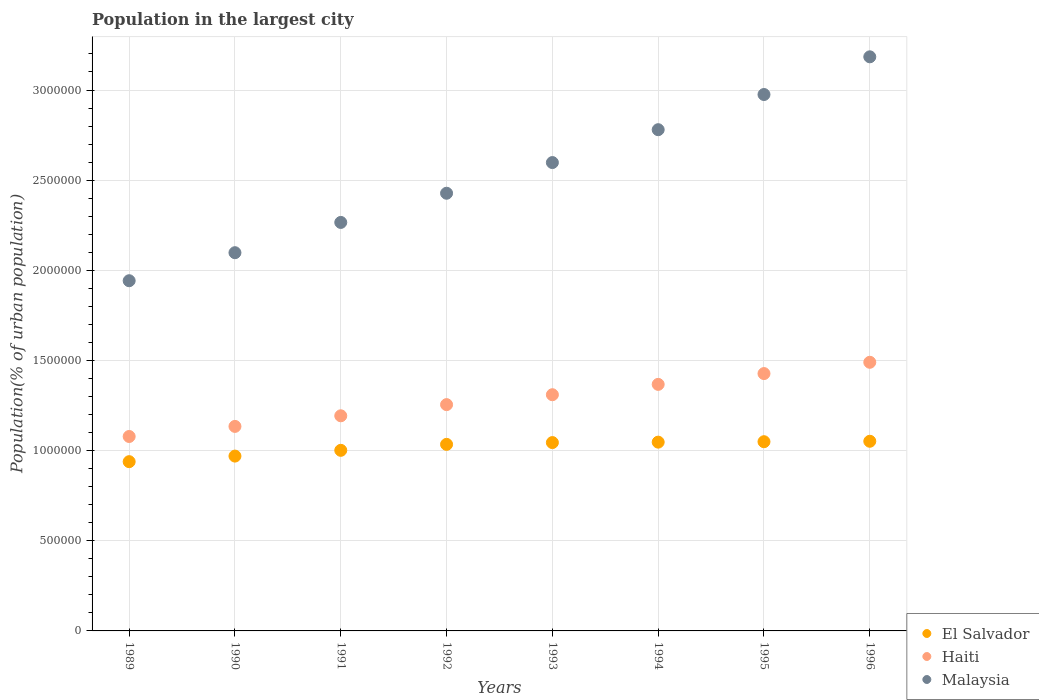What is the population in the largest city in Haiti in 1990?
Offer a terse response. 1.13e+06. Across all years, what is the maximum population in the largest city in Haiti?
Your answer should be compact. 1.49e+06. Across all years, what is the minimum population in the largest city in El Salvador?
Give a very brief answer. 9.39e+05. In which year was the population in the largest city in El Salvador minimum?
Make the answer very short. 1989. What is the total population in the largest city in Haiti in the graph?
Keep it short and to the point. 1.03e+07. What is the difference between the population in the largest city in Haiti in 1995 and that in 1996?
Offer a very short reply. -6.26e+04. What is the difference between the population in the largest city in Haiti in 1991 and the population in the largest city in Malaysia in 1989?
Make the answer very short. -7.49e+05. What is the average population in the largest city in El Salvador per year?
Provide a short and direct response. 1.02e+06. In the year 1989, what is the difference between the population in the largest city in El Salvador and population in the largest city in Malaysia?
Provide a short and direct response. -1.00e+06. What is the ratio of the population in the largest city in Haiti in 1989 to that in 1994?
Your response must be concise. 0.79. Is the population in the largest city in El Salvador in 1991 less than that in 1992?
Your answer should be very brief. Yes. What is the difference between the highest and the second highest population in the largest city in Haiti?
Offer a very short reply. 6.26e+04. What is the difference between the highest and the lowest population in the largest city in Haiti?
Keep it short and to the point. 4.12e+05. In how many years, is the population in the largest city in Haiti greater than the average population in the largest city in Haiti taken over all years?
Ensure brevity in your answer.  4. Does the population in the largest city in Malaysia monotonically increase over the years?
Your answer should be compact. Yes. Is the population in the largest city in El Salvador strictly greater than the population in the largest city in Haiti over the years?
Offer a very short reply. No. Is the population in the largest city in Malaysia strictly less than the population in the largest city in Haiti over the years?
Give a very brief answer. No. What is the difference between two consecutive major ticks on the Y-axis?
Keep it short and to the point. 5.00e+05. Does the graph contain any zero values?
Ensure brevity in your answer.  No. Does the graph contain grids?
Your answer should be compact. Yes. Where does the legend appear in the graph?
Your answer should be compact. Bottom right. How are the legend labels stacked?
Offer a terse response. Vertical. What is the title of the graph?
Ensure brevity in your answer.  Population in the largest city. What is the label or title of the X-axis?
Provide a short and direct response. Years. What is the label or title of the Y-axis?
Keep it short and to the point. Population(% of urban population). What is the Population(% of urban population) in El Salvador in 1989?
Ensure brevity in your answer.  9.39e+05. What is the Population(% of urban population) of Haiti in 1989?
Ensure brevity in your answer.  1.08e+06. What is the Population(% of urban population) of Malaysia in 1989?
Your response must be concise. 1.94e+06. What is the Population(% of urban population) of El Salvador in 1990?
Your answer should be compact. 9.70e+05. What is the Population(% of urban population) of Haiti in 1990?
Your answer should be compact. 1.13e+06. What is the Population(% of urban population) of Malaysia in 1990?
Offer a very short reply. 2.10e+06. What is the Population(% of urban population) in El Salvador in 1991?
Provide a succinct answer. 1.00e+06. What is the Population(% of urban population) of Haiti in 1991?
Offer a very short reply. 1.19e+06. What is the Population(% of urban population) of Malaysia in 1991?
Give a very brief answer. 2.27e+06. What is the Population(% of urban population) of El Salvador in 1992?
Your answer should be very brief. 1.03e+06. What is the Population(% of urban population) of Haiti in 1992?
Your answer should be compact. 1.26e+06. What is the Population(% of urban population) in Malaysia in 1992?
Provide a succinct answer. 2.43e+06. What is the Population(% of urban population) of El Salvador in 1993?
Your answer should be very brief. 1.04e+06. What is the Population(% of urban population) of Haiti in 1993?
Offer a terse response. 1.31e+06. What is the Population(% of urban population) of Malaysia in 1993?
Offer a very short reply. 2.60e+06. What is the Population(% of urban population) in El Salvador in 1994?
Your answer should be very brief. 1.05e+06. What is the Population(% of urban population) of Haiti in 1994?
Offer a terse response. 1.37e+06. What is the Population(% of urban population) in Malaysia in 1994?
Offer a very short reply. 2.78e+06. What is the Population(% of urban population) of El Salvador in 1995?
Give a very brief answer. 1.05e+06. What is the Population(% of urban population) of Haiti in 1995?
Ensure brevity in your answer.  1.43e+06. What is the Population(% of urban population) of Malaysia in 1995?
Provide a succinct answer. 2.97e+06. What is the Population(% of urban population) of El Salvador in 1996?
Ensure brevity in your answer.  1.05e+06. What is the Population(% of urban population) of Haiti in 1996?
Offer a terse response. 1.49e+06. What is the Population(% of urban population) of Malaysia in 1996?
Give a very brief answer. 3.18e+06. Across all years, what is the maximum Population(% of urban population) in El Salvador?
Provide a short and direct response. 1.05e+06. Across all years, what is the maximum Population(% of urban population) of Haiti?
Make the answer very short. 1.49e+06. Across all years, what is the maximum Population(% of urban population) of Malaysia?
Give a very brief answer. 3.18e+06. Across all years, what is the minimum Population(% of urban population) of El Salvador?
Keep it short and to the point. 9.39e+05. Across all years, what is the minimum Population(% of urban population) of Haiti?
Provide a succinct answer. 1.08e+06. Across all years, what is the minimum Population(% of urban population) in Malaysia?
Your response must be concise. 1.94e+06. What is the total Population(% of urban population) in El Salvador in the graph?
Ensure brevity in your answer.  8.14e+06. What is the total Population(% of urban population) in Haiti in the graph?
Make the answer very short. 1.03e+07. What is the total Population(% of urban population) of Malaysia in the graph?
Ensure brevity in your answer.  2.03e+07. What is the difference between the Population(% of urban population) in El Salvador in 1989 and that in 1990?
Ensure brevity in your answer.  -3.09e+04. What is the difference between the Population(% of urban population) of Haiti in 1989 and that in 1990?
Your response must be concise. -5.59e+04. What is the difference between the Population(% of urban population) in Malaysia in 1989 and that in 1990?
Give a very brief answer. -1.55e+05. What is the difference between the Population(% of urban population) in El Salvador in 1989 and that in 1991?
Keep it short and to the point. -6.29e+04. What is the difference between the Population(% of urban population) of Haiti in 1989 and that in 1991?
Keep it short and to the point. -1.15e+05. What is the difference between the Population(% of urban population) in Malaysia in 1989 and that in 1991?
Your answer should be very brief. -3.23e+05. What is the difference between the Population(% of urban population) in El Salvador in 1989 and that in 1992?
Your answer should be very brief. -9.59e+04. What is the difference between the Population(% of urban population) in Haiti in 1989 and that in 1992?
Ensure brevity in your answer.  -1.77e+05. What is the difference between the Population(% of urban population) in Malaysia in 1989 and that in 1992?
Your answer should be compact. -4.85e+05. What is the difference between the Population(% of urban population) of El Salvador in 1989 and that in 1993?
Your answer should be very brief. -1.06e+05. What is the difference between the Population(% of urban population) of Haiti in 1989 and that in 1993?
Your answer should be very brief. -2.32e+05. What is the difference between the Population(% of urban population) of Malaysia in 1989 and that in 1993?
Ensure brevity in your answer.  -6.55e+05. What is the difference between the Population(% of urban population) of El Salvador in 1989 and that in 1994?
Your answer should be very brief. -1.08e+05. What is the difference between the Population(% of urban population) of Haiti in 1989 and that in 1994?
Keep it short and to the point. -2.89e+05. What is the difference between the Population(% of urban population) of Malaysia in 1989 and that in 1994?
Make the answer very short. -8.38e+05. What is the difference between the Population(% of urban population) of El Salvador in 1989 and that in 1995?
Ensure brevity in your answer.  -1.11e+05. What is the difference between the Population(% of urban population) of Haiti in 1989 and that in 1995?
Make the answer very short. -3.49e+05. What is the difference between the Population(% of urban population) of Malaysia in 1989 and that in 1995?
Your response must be concise. -1.03e+06. What is the difference between the Population(% of urban population) in El Salvador in 1989 and that in 1996?
Provide a short and direct response. -1.13e+05. What is the difference between the Population(% of urban population) of Haiti in 1989 and that in 1996?
Make the answer very short. -4.12e+05. What is the difference between the Population(% of urban population) in Malaysia in 1989 and that in 1996?
Ensure brevity in your answer.  -1.24e+06. What is the difference between the Population(% of urban population) of El Salvador in 1990 and that in 1991?
Provide a succinct answer. -3.20e+04. What is the difference between the Population(% of urban population) in Haiti in 1990 and that in 1991?
Your answer should be compact. -5.88e+04. What is the difference between the Population(% of urban population) of Malaysia in 1990 and that in 1991?
Provide a short and direct response. -1.68e+05. What is the difference between the Population(% of urban population) in El Salvador in 1990 and that in 1992?
Offer a very short reply. -6.50e+04. What is the difference between the Population(% of urban population) of Haiti in 1990 and that in 1992?
Keep it short and to the point. -1.21e+05. What is the difference between the Population(% of urban population) of Malaysia in 1990 and that in 1992?
Your response must be concise. -3.30e+05. What is the difference between the Population(% of urban population) of El Salvador in 1990 and that in 1993?
Offer a terse response. -7.49e+04. What is the difference between the Population(% of urban population) of Haiti in 1990 and that in 1993?
Offer a terse response. -1.76e+05. What is the difference between the Population(% of urban population) in Malaysia in 1990 and that in 1993?
Provide a short and direct response. -5.00e+05. What is the difference between the Population(% of urban population) of El Salvador in 1990 and that in 1994?
Your response must be concise. -7.74e+04. What is the difference between the Population(% of urban population) of Haiti in 1990 and that in 1994?
Provide a succinct answer. -2.33e+05. What is the difference between the Population(% of urban population) of Malaysia in 1990 and that in 1994?
Provide a short and direct response. -6.82e+05. What is the difference between the Population(% of urban population) in El Salvador in 1990 and that in 1995?
Provide a short and direct response. -7.98e+04. What is the difference between the Population(% of urban population) in Haiti in 1990 and that in 1995?
Offer a very short reply. -2.93e+05. What is the difference between the Population(% of urban population) in Malaysia in 1990 and that in 1995?
Offer a very short reply. -8.77e+05. What is the difference between the Population(% of urban population) of El Salvador in 1990 and that in 1996?
Your response must be concise. -8.22e+04. What is the difference between the Population(% of urban population) in Haiti in 1990 and that in 1996?
Make the answer very short. -3.56e+05. What is the difference between the Population(% of urban population) of Malaysia in 1990 and that in 1996?
Offer a very short reply. -1.09e+06. What is the difference between the Population(% of urban population) in El Salvador in 1991 and that in 1992?
Give a very brief answer. -3.31e+04. What is the difference between the Population(% of urban population) of Haiti in 1991 and that in 1992?
Keep it short and to the point. -6.20e+04. What is the difference between the Population(% of urban population) of Malaysia in 1991 and that in 1992?
Provide a succinct answer. -1.62e+05. What is the difference between the Population(% of urban population) of El Salvador in 1991 and that in 1993?
Make the answer very short. -4.30e+04. What is the difference between the Population(% of urban population) in Haiti in 1991 and that in 1993?
Provide a succinct answer. -1.17e+05. What is the difference between the Population(% of urban population) in Malaysia in 1991 and that in 1993?
Provide a succinct answer. -3.32e+05. What is the difference between the Population(% of urban population) in El Salvador in 1991 and that in 1994?
Ensure brevity in your answer.  -4.54e+04. What is the difference between the Population(% of urban population) of Haiti in 1991 and that in 1994?
Provide a short and direct response. -1.74e+05. What is the difference between the Population(% of urban population) of Malaysia in 1991 and that in 1994?
Give a very brief answer. -5.14e+05. What is the difference between the Population(% of urban population) of El Salvador in 1991 and that in 1995?
Make the answer very short. -4.78e+04. What is the difference between the Population(% of urban population) of Haiti in 1991 and that in 1995?
Offer a very short reply. -2.34e+05. What is the difference between the Population(% of urban population) in Malaysia in 1991 and that in 1995?
Provide a succinct answer. -7.09e+05. What is the difference between the Population(% of urban population) of El Salvador in 1991 and that in 1996?
Your answer should be very brief. -5.03e+04. What is the difference between the Population(% of urban population) in Haiti in 1991 and that in 1996?
Provide a succinct answer. -2.97e+05. What is the difference between the Population(% of urban population) of Malaysia in 1991 and that in 1996?
Your answer should be very brief. -9.19e+05. What is the difference between the Population(% of urban population) in El Salvador in 1992 and that in 1993?
Give a very brief answer. -9927. What is the difference between the Population(% of urban population) of Haiti in 1992 and that in 1993?
Make the answer very short. -5.49e+04. What is the difference between the Population(% of urban population) in Malaysia in 1992 and that in 1993?
Provide a succinct answer. -1.70e+05. What is the difference between the Population(% of urban population) in El Salvador in 1992 and that in 1994?
Your answer should be compact. -1.23e+04. What is the difference between the Population(% of urban population) of Haiti in 1992 and that in 1994?
Your answer should be compact. -1.12e+05. What is the difference between the Population(% of urban population) in Malaysia in 1992 and that in 1994?
Ensure brevity in your answer.  -3.52e+05. What is the difference between the Population(% of urban population) in El Salvador in 1992 and that in 1995?
Offer a terse response. -1.48e+04. What is the difference between the Population(% of urban population) in Haiti in 1992 and that in 1995?
Offer a terse response. -1.72e+05. What is the difference between the Population(% of urban population) in Malaysia in 1992 and that in 1995?
Offer a very short reply. -5.48e+05. What is the difference between the Population(% of urban population) of El Salvador in 1992 and that in 1996?
Offer a terse response. -1.72e+04. What is the difference between the Population(% of urban population) in Haiti in 1992 and that in 1996?
Make the answer very short. -2.35e+05. What is the difference between the Population(% of urban population) of Malaysia in 1992 and that in 1996?
Ensure brevity in your answer.  -7.57e+05. What is the difference between the Population(% of urban population) in El Salvador in 1993 and that in 1994?
Your answer should be compact. -2417. What is the difference between the Population(% of urban population) in Haiti in 1993 and that in 1994?
Provide a succinct answer. -5.74e+04. What is the difference between the Population(% of urban population) in Malaysia in 1993 and that in 1994?
Your answer should be compact. -1.82e+05. What is the difference between the Population(% of urban population) of El Salvador in 1993 and that in 1995?
Your answer should be very brief. -4839. What is the difference between the Population(% of urban population) in Haiti in 1993 and that in 1995?
Provide a succinct answer. -1.17e+05. What is the difference between the Population(% of urban population) of Malaysia in 1993 and that in 1995?
Your answer should be compact. -3.77e+05. What is the difference between the Population(% of urban population) in El Salvador in 1993 and that in 1996?
Make the answer very short. -7271. What is the difference between the Population(% of urban population) of Haiti in 1993 and that in 1996?
Your answer should be compact. -1.80e+05. What is the difference between the Population(% of urban population) in Malaysia in 1993 and that in 1996?
Give a very brief answer. -5.86e+05. What is the difference between the Population(% of urban population) of El Salvador in 1994 and that in 1995?
Offer a terse response. -2422. What is the difference between the Population(% of urban population) of Haiti in 1994 and that in 1995?
Make the answer very short. -5.99e+04. What is the difference between the Population(% of urban population) in Malaysia in 1994 and that in 1995?
Offer a very short reply. -1.95e+05. What is the difference between the Population(% of urban population) of El Salvador in 1994 and that in 1996?
Your answer should be very brief. -4854. What is the difference between the Population(% of urban population) in Haiti in 1994 and that in 1996?
Provide a succinct answer. -1.23e+05. What is the difference between the Population(% of urban population) of Malaysia in 1994 and that in 1996?
Provide a short and direct response. -4.04e+05. What is the difference between the Population(% of urban population) in El Salvador in 1995 and that in 1996?
Offer a terse response. -2432. What is the difference between the Population(% of urban population) of Haiti in 1995 and that in 1996?
Your answer should be very brief. -6.26e+04. What is the difference between the Population(% of urban population) of Malaysia in 1995 and that in 1996?
Provide a short and direct response. -2.09e+05. What is the difference between the Population(% of urban population) in El Salvador in 1989 and the Population(% of urban population) in Haiti in 1990?
Ensure brevity in your answer.  -1.96e+05. What is the difference between the Population(% of urban population) of El Salvador in 1989 and the Population(% of urban population) of Malaysia in 1990?
Give a very brief answer. -1.16e+06. What is the difference between the Population(% of urban population) of Haiti in 1989 and the Population(% of urban population) of Malaysia in 1990?
Make the answer very short. -1.02e+06. What is the difference between the Population(% of urban population) in El Salvador in 1989 and the Population(% of urban population) in Haiti in 1991?
Your answer should be compact. -2.54e+05. What is the difference between the Population(% of urban population) in El Salvador in 1989 and the Population(% of urban population) in Malaysia in 1991?
Give a very brief answer. -1.33e+06. What is the difference between the Population(% of urban population) of Haiti in 1989 and the Population(% of urban population) of Malaysia in 1991?
Provide a succinct answer. -1.19e+06. What is the difference between the Population(% of urban population) of El Salvador in 1989 and the Population(% of urban population) of Haiti in 1992?
Your answer should be very brief. -3.16e+05. What is the difference between the Population(% of urban population) of El Salvador in 1989 and the Population(% of urban population) of Malaysia in 1992?
Your answer should be very brief. -1.49e+06. What is the difference between the Population(% of urban population) in Haiti in 1989 and the Population(% of urban population) in Malaysia in 1992?
Ensure brevity in your answer.  -1.35e+06. What is the difference between the Population(% of urban population) of El Salvador in 1989 and the Population(% of urban population) of Haiti in 1993?
Your response must be concise. -3.71e+05. What is the difference between the Population(% of urban population) in El Salvador in 1989 and the Population(% of urban population) in Malaysia in 1993?
Keep it short and to the point. -1.66e+06. What is the difference between the Population(% of urban population) of Haiti in 1989 and the Population(% of urban population) of Malaysia in 1993?
Ensure brevity in your answer.  -1.52e+06. What is the difference between the Population(% of urban population) in El Salvador in 1989 and the Population(% of urban population) in Haiti in 1994?
Your response must be concise. -4.29e+05. What is the difference between the Population(% of urban population) of El Salvador in 1989 and the Population(% of urban population) of Malaysia in 1994?
Your response must be concise. -1.84e+06. What is the difference between the Population(% of urban population) of Haiti in 1989 and the Population(% of urban population) of Malaysia in 1994?
Your response must be concise. -1.70e+06. What is the difference between the Population(% of urban population) of El Salvador in 1989 and the Population(% of urban population) of Haiti in 1995?
Provide a short and direct response. -4.89e+05. What is the difference between the Population(% of urban population) of El Salvador in 1989 and the Population(% of urban population) of Malaysia in 1995?
Ensure brevity in your answer.  -2.04e+06. What is the difference between the Population(% of urban population) of Haiti in 1989 and the Population(% of urban population) of Malaysia in 1995?
Ensure brevity in your answer.  -1.90e+06. What is the difference between the Population(% of urban population) of El Salvador in 1989 and the Population(% of urban population) of Haiti in 1996?
Keep it short and to the point. -5.51e+05. What is the difference between the Population(% of urban population) of El Salvador in 1989 and the Population(% of urban population) of Malaysia in 1996?
Give a very brief answer. -2.25e+06. What is the difference between the Population(% of urban population) in Haiti in 1989 and the Population(% of urban population) in Malaysia in 1996?
Offer a very short reply. -2.11e+06. What is the difference between the Population(% of urban population) in El Salvador in 1990 and the Population(% of urban population) in Haiti in 1991?
Give a very brief answer. -2.23e+05. What is the difference between the Population(% of urban population) of El Salvador in 1990 and the Population(% of urban population) of Malaysia in 1991?
Make the answer very short. -1.30e+06. What is the difference between the Population(% of urban population) in Haiti in 1990 and the Population(% of urban population) in Malaysia in 1991?
Keep it short and to the point. -1.13e+06. What is the difference between the Population(% of urban population) of El Salvador in 1990 and the Population(% of urban population) of Haiti in 1992?
Ensure brevity in your answer.  -2.85e+05. What is the difference between the Population(% of urban population) in El Salvador in 1990 and the Population(% of urban population) in Malaysia in 1992?
Your response must be concise. -1.46e+06. What is the difference between the Population(% of urban population) in Haiti in 1990 and the Population(% of urban population) in Malaysia in 1992?
Your answer should be very brief. -1.29e+06. What is the difference between the Population(% of urban population) of El Salvador in 1990 and the Population(% of urban population) of Haiti in 1993?
Offer a terse response. -3.40e+05. What is the difference between the Population(% of urban population) of El Salvador in 1990 and the Population(% of urban population) of Malaysia in 1993?
Your answer should be compact. -1.63e+06. What is the difference between the Population(% of urban population) in Haiti in 1990 and the Population(% of urban population) in Malaysia in 1993?
Offer a terse response. -1.46e+06. What is the difference between the Population(% of urban population) in El Salvador in 1990 and the Population(% of urban population) in Haiti in 1994?
Your answer should be compact. -3.98e+05. What is the difference between the Population(% of urban population) of El Salvador in 1990 and the Population(% of urban population) of Malaysia in 1994?
Ensure brevity in your answer.  -1.81e+06. What is the difference between the Population(% of urban population) in Haiti in 1990 and the Population(% of urban population) in Malaysia in 1994?
Offer a terse response. -1.65e+06. What is the difference between the Population(% of urban population) of El Salvador in 1990 and the Population(% of urban population) of Haiti in 1995?
Ensure brevity in your answer.  -4.58e+05. What is the difference between the Population(% of urban population) of El Salvador in 1990 and the Population(% of urban population) of Malaysia in 1995?
Offer a very short reply. -2.01e+06. What is the difference between the Population(% of urban population) in Haiti in 1990 and the Population(% of urban population) in Malaysia in 1995?
Provide a short and direct response. -1.84e+06. What is the difference between the Population(% of urban population) of El Salvador in 1990 and the Population(% of urban population) of Haiti in 1996?
Your response must be concise. -5.20e+05. What is the difference between the Population(% of urban population) of El Salvador in 1990 and the Population(% of urban population) of Malaysia in 1996?
Ensure brevity in your answer.  -2.21e+06. What is the difference between the Population(% of urban population) of Haiti in 1990 and the Population(% of urban population) of Malaysia in 1996?
Offer a very short reply. -2.05e+06. What is the difference between the Population(% of urban population) of El Salvador in 1991 and the Population(% of urban population) of Haiti in 1992?
Give a very brief answer. -2.53e+05. What is the difference between the Population(% of urban population) in El Salvador in 1991 and the Population(% of urban population) in Malaysia in 1992?
Provide a short and direct response. -1.43e+06. What is the difference between the Population(% of urban population) of Haiti in 1991 and the Population(% of urban population) of Malaysia in 1992?
Offer a very short reply. -1.23e+06. What is the difference between the Population(% of urban population) of El Salvador in 1991 and the Population(% of urban population) of Haiti in 1993?
Make the answer very short. -3.08e+05. What is the difference between the Population(% of urban population) in El Salvador in 1991 and the Population(% of urban population) in Malaysia in 1993?
Give a very brief answer. -1.60e+06. What is the difference between the Population(% of urban population) of Haiti in 1991 and the Population(% of urban population) of Malaysia in 1993?
Offer a very short reply. -1.40e+06. What is the difference between the Population(% of urban population) in El Salvador in 1991 and the Population(% of urban population) in Haiti in 1994?
Keep it short and to the point. -3.66e+05. What is the difference between the Population(% of urban population) in El Salvador in 1991 and the Population(% of urban population) in Malaysia in 1994?
Make the answer very short. -1.78e+06. What is the difference between the Population(% of urban population) in Haiti in 1991 and the Population(% of urban population) in Malaysia in 1994?
Your answer should be very brief. -1.59e+06. What is the difference between the Population(% of urban population) in El Salvador in 1991 and the Population(% of urban population) in Haiti in 1995?
Your answer should be very brief. -4.26e+05. What is the difference between the Population(% of urban population) of El Salvador in 1991 and the Population(% of urban population) of Malaysia in 1995?
Ensure brevity in your answer.  -1.97e+06. What is the difference between the Population(% of urban population) in Haiti in 1991 and the Population(% of urban population) in Malaysia in 1995?
Your answer should be very brief. -1.78e+06. What is the difference between the Population(% of urban population) in El Salvador in 1991 and the Population(% of urban population) in Haiti in 1996?
Keep it short and to the point. -4.88e+05. What is the difference between the Population(% of urban population) in El Salvador in 1991 and the Population(% of urban population) in Malaysia in 1996?
Offer a terse response. -2.18e+06. What is the difference between the Population(% of urban population) in Haiti in 1991 and the Population(% of urban population) in Malaysia in 1996?
Provide a succinct answer. -1.99e+06. What is the difference between the Population(% of urban population) of El Salvador in 1992 and the Population(% of urban population) of Haiti in 1993?
Provide a short and direct response. -2.75e+05. What is the difference between the Population(% of urban population) of El Salvador in 1992 and the Population(% of urban population) of Malaysia in 1993?
Keep it short and to the point. -1.56e+06. What is the difference between the Population(% of urban population) in Haiti in 1992 and the Population(% of urban population) in Malaysia in 1993?
Provide a short and direct response. -1.34e+06. What is the difference between the Population(% of urban population) in El Salvador in 1992 and the Population(% of urban population) in Haiti in 1994?
Give a very brief answer. -3.33e+05. What is the difference between the Population(% of urban population) of El Salvador in 1992 and the Population(% of urban population) of Malaysia in 1994?
Your answer should be compact. -1.75e+06. What is the difference between the Population(% of urban population) in Haiti in 1992 and the Population(% of urban population) in Malaysia in 1994?
Your response must be concise. -1.52e+06. What is the difference between the Population(% of urban population) in El Salvador in 1992 and the Population(% of urban population) in Haiti in 1995?
Make the answer very short. -3.93e+05. What is the difference between the Population(% of urban population) in El Salvador in 1992 and the Population(% of urban population) in Malaysia in 1995?
Your answer should be very brief. -1.94e+06. What is the difference between the Population(% of urban population) of Haiti in 1992 and the Population(% of urban population) of Malaysia in 1995?
Your answer should be compact. -1.72e+06. What is the difference between the Population(% of urban population) in El Salvador in 1992 and the Population(% of urban population) in Haiti in 1996?
Offer a terse response. -4.55e+05. What is the difference between the Population(% of urban population) in El Salvador in 1992 and the Population(% of urban population) in Malaysia in 1996?
Ensure brevity in your answer.  -2.15e+06. What is the difference between the Population(% of urban population) of Haiti in 1992 and the Population(% of urban population) of Malaysia in 1996?
Make the answer very short. -1.93e+06. What is the difference between the Population(% of urban population) in El Salvador in 1993 and the Population(% of urban population) in Haiti in 1994?
Ensure brevity in your answer.  -3.23e+05. What is the difference between the Population(% of urban population) of El Salvador in 1993 and the Population(% of urban population) of Malaysia in 1994?
Make the answer very short. -1.74e+06. What is the difference between the Population(% of urban population) in Haiti in 1993 and the Population(% of urban population) in Malaysia in 1994?
Your answer should be very brief. -1.47e+06. What is the difference between the Population(% of urban population) of El Salvador in 1993 and the Population(% of urban population) of Haiti in 1995?
Your response must be concise. -3.83e+05. What is the difference between the Population(% of urban population) in El Salvador in 1993 and the Population(% of urban population) in Malaysia in 1995?
Provide a succinct answer. -1.93e+06. What is the difference between the Population(% of urban population) of Haiti in 1993 and the Population(% of urban population) of Malaysia in 1995?
Your response must be concise. -1.66e+06. What is the difference between the Population(% of urban population) of El Salvador in 1993 and the Population(% of urban population) of Haiti in 1996?
Make the answer very short. -4.45e+05. What is the difference between the Population(% of urban population) in El Salvador in 1993 and the Population(% of urban population) in Malaysia in 1996?
Provide a short and direct response. -2.14e+06. What is the difference between the Population(% of urban population) of Haiti in 1993 and the Population(% of urban population) of Malaysia in 1996?
Offer a terse response. -1.87e+06. What is the difference between the Population(% of urban population) in El Salvador in 1994 and the Population(% of urban population) in Haiti in 1995?
Keep it short and to the point. -3.80e+05. What is the difference between the Population(% of urban population) of El Salvador in 1994 and the Population(% of urban population) of Malaysia in 1995?
Your answer should be very brief. -1.93e+06. What is the difference between the Population(% of urban population) in Haiti in 1994 and the Population(% of urban population) in Malaysia in 1995?
Ensure brevity in your answer.  -1.61e+06. What is the difference between the Population(% of urban population) of El Salvador in 1994 and the Population(% of urban population) of Haiti in 1996?
Your answer should be very brief. -4.43e+05. What is the difference between the Population(% of urban population) in El Salvador in 1994 and the Population(% of urban population) in Malaysia in 1996?
Your answer should be compact. -2.14e+06. What is the difference between the Population(% of urban population) of Haiti in 1994 and the Population(% of urban population) of Malaysia in 1996?
Give a very brief answer. -1.82e+06. What is the difference between the Population(% of urban population) of El Salvador in 1995 and the Population(% of urban population) of Haiti in 1996?
Provide a short and direct response. -4.40e+05. What is the difference between the Population(% of urban population) in El Salvador in 1995 and the Population(% of urban population) in Malaysia in 1996?
Keep it short and to the point. -2.13e+06. What is the difference between the Population(% of urban population) of Haiti in 1995 and the Population(% of urban population) of Malaysia in 1996?
Provide a succinct answer. -1.76e+06. What is the average Population(% of urban population) of El Salvador per year?
Keep it short and to the point. 1.02e+06. What is the average Population(% of urban population) of Haiti per year?
Offer a very short reply. 1.28e+06. What is the average Population(% of urban population) of Malaysia per year?
Ensure brevity in your answer.  2.53e+06. In the year 1989, what is the difference between the Population(% of urban population) in El Salvador and Population(% of urban population) in Haiti?
Your answer should be compact. -1.40e+05. In the year 1989, what is the difference between the Population(% of urban population) of El Salvador and Population(% of urban population) of Malaysia?
Your response must be concise. -1.00e+06. In the year 1989, what is the difference between the Population(% of urban population) of Haiti and Population(% of urban population) of Malaysia?
Your answer should be very brief. -8.64e+05. In the year 1990, what is the difference between the Population(% of urban population) of El Salvador and Population(% of urban population) of Haiti?
Provide a short and direct response. -1.65e+05. In the year 1990, what is the difference between the Population(% of urban population) in El Salvador and Population(% of urban population) in Malaysia?
Offer a very short reply. -1.13e+06. In the year 1990, what is the difference between the Population(% of urban population) of Haiti and Population(% of urban population) of Malaysia?
Provide a succinct answer. -9.63e+05. In the year 1991, what is the difference between the Population(% of urban population) in El Salvador and Population(% of urban population) in Haiti?
Your answer should be very brief. -1.92e+05. In the year 1991, what is the difference between the Population(% of urban population) in El Salvador and Population(% of urban population) in Malaysia?
Ensure brevity in your answer.  -1.26e+06. In the year 1991, what is the difference between the Population(% of urban population) of Haiti and Population(% of urban population) of Malaysia?
Ensure brevity in your answer.  -1.07e+06. In the year 1992, what is the difference between the Population(% of urban population) of El Salvador and Population(% of urban population) of Haiti?
Make the answer very short. -2.20e+05. In the year 1992, what is the difference between the Population(% of urban population) in El Salvador and Population(% of urban population) in Malaysia?
Offer a very short reply. -1.39e+06. In the year 1992, what is the difference between the Population(% of urban population) in Haiti and Population(% of urban population) in Malaysia?
Provide a succinct answer. -1.17e+06. In the year 1993, what is the difference between the Population(% of urban population) of El Salvador and Population(% of urban population) of Haiti?
Offer a very short reply. -2.65e+05. In the year 1993, what is the difference between the Population(% of urban population) in El Salvador and Population(% of urban population) in Malaysia?
Keep it short and to the point. -1.55e+06. In the year 1993, what is the difference between the Population(% of urban population) in Haiti and Population(% of urban population) in Malaysia?
Keep it short and to the point. -1.29e+06. In the year 1994, what is the difference between the Population(% of urban population) in El Salvador and Population(% of urban population) in Haiti?
Make the answer very short. -3.20e+05. In the year 1994, what is the difference between the Population(% of urban population) of El Salvador and Population(% of urban population) of Malaysia?
Your response must be concise. -1.73e+06. In the year 1994, what is the difference between the Population(% of urban population) in Haiti and Population(% of urban population) in Malaysia?
Keep it short and to the point. -1.41e+06. In the year 1995, what is the difference between the Population(% of urban population) of El Salvador and Population(% of urban population) of Haiti?
Your answer should be compact. -3.78e+05. In the year 1995, what is the difference between the Population(% of urban population) in El Salvador and Population(% of urban population) in Malaysia?
Give a very brief answer. -1.93e+06. In the year 1995, what is the difference between the Population(% of urban population) in Haiti and Population(% of urban population) in Malaysia?
Your answer should be compact. -1.55e+06. In the year 1996, what is the difference between the Population(% of urban population) in El Salvador and Population(% of urban population) in Haiti?
Ensure brevity in your answer.  -4.38e+05. In the year 1996, what is the difference between the Population(% of urban population) in El Salvador and Population(% of urban population) in Malaysia?
Make the answer very short. -2.13e+06. In the year 1996, what is the difference between the Population(% of urban population) of Haiti and Population(% of urban population) of Malaysia?
Provide a short and direct response. -1.69e+06. What is the ratio of the Population(% of urban population) of El Salvador in 1989 to that in 1990?
Your answer should be compact. 0.97. What is the ratio of the Population(% of urban population) in Haiti in 1989 to that in 1990?
Your answer should be compact. 0.95. What is the ratio of the Population(% of urban population) of Malaysia in 1989 to that in 1990?
Give a very brief answer. 0.93. What is the ratio of the Population(% of urban population) of El Salvador in 1989 to that in 1991?
Your response must be concise. 0.94. What is the ratio of the Population(% of urban population) of Haiti in 1989 to that in 1991?
Ensure brevity in your answer.  0.9. What is the ratio of the Population(% of urban population) of Malaysia in 1989 to that in 1991?
Make the answer very short. 0.86. What is the ratio of the Population(% of urban population) of El Salvador in 1989 to that in 1992?
Keep it short and to the point. 0.91. What is the ratio of the Population(% of urban population) of Haiti in 1989 to that in 1992?
Make the answer very short. 0.86. What is the ratio of the Population(% of urban population) in Malaysia in 1989 to that in 1992?
Your answer should be very brief. 0.8. What is the ratio of the Population(% of urban population) in El Salvador in 1989 to that in 1993?
Your response must be concise. 0.9. What is the ratio of the Population(% of urban population) of Haiti in 1989 to that in 1993?
Provide a succinct answer. 0.82. What is the ratio of the Population(% of urban population) in Malaysia in 1989 to that in 1993?
Give a very brief answer. 0.75. What is the ratio of the Population(% of urban population) of El Salvador in 1989 to that in 1994?
Your response must be concise. 0.9. What is the ratio of the Population(% of urban population) of Haiti in 1989 to that in 1994?
Your response must be concise. 0.79. What is the ratio of the Population(% of urban population) in Malaysia in 1989 to that in 1994?
Provide a short and direct response. 0.7. What is the ratio of the Population(% of urban population) in El Salvador in 1989 to that in 1995?
Your answer should be compact. 0.89. What is the ratio of the Population(% of urban population) of Haiti in 1989 to that in 1995?
Give a very brief answer. 0.76. What is the ratio of the Population(% of urban population) in Malaysia in 1989 to that in 1995?
Ensure brevity in your answer.  0.65. What is the ratio of the Population(% of urban population) in El Salvador in 1989 to that in 1996?
Your answer should be very brief. 0.89. What is the ratio of the Population(% of urban population) in Haiti in 1989 to that in 1996?
Provide a short and direct response. 0.72. What is the ratio of the Population(% of urban population) in Malaysia in 1989 to that in 1996?
Offer a very short reply. 0.61. What is the ratio of the Population(% of urban population) in El Salvador in 1990 to that in 1991?
Your answer should be very brief. 0.97. What is the ratio of the Population(% of urban population) of Haiti in 1990 to that in 1991?
Your answer should be very brief. 0.95. What is the ratio of the Population(% of urban population) in Malaysia in 1990 to that in 1991?
Make the answer very short. 0.93. What is the ratio of the Population(% of urban population) of El Salvador in 1990 to that in 1992?
Provide a short and direct response. 0.94. What is the ratio of the Population(% of urban population) of Haiti in 1990 to that in 1992?
Your answer should be compact. 0.9. What is the ratio of the Population(% of urban population) of Malaysia in 1990 to that in 1992?
Provide a succinct answer. 0.86. What is the ratio of the Population(% of urban population) in El Salvador in 1990 to that in 1993?
Offer a very short reply. 0.93. What is the ratio of the Population(% of urban population) in Haiti in 1990 to that in 1993?
Provide a succinct answer. 0.87. What is the ratio of the Population(% of urban population) in Malaysia in 1990 to that in 1993?
Offer a very short reply. 0.81. What is the ratio of the Population(% of urban population) in El Salvador in 1990 to that in 1994?
Your response must be concise. 0.93. What is the ratio of the Population(% of urban population) in Haiti in 1990 to that in 1994?
Provide a short and direct response. 0.83. What is the ratio of the Population(% of urban population) of Malaysia in 1990 to that in 1994?
Your answer should be very brief. 0.75. What is the ratio of the Population(% of urban population) in El Salvador in 1990 to that in 1995?
Offer a terse response. 0.92. What is the ratio of the Population(% of urban population) of Haiti in 1990 to that in 1995?
Offer a very short reply. 0.79. What is the ratio of the Population(% of urban population) in Malaysia in 1990 to that in 1995?
Offer a very short reply. 0.71. What is the ratio of the Population(% of urban population) in El Salvador in 1990 to that in 1996?
Offer a very short reply. 0.92. What is the ratio of the Population(% of urban population) in Haiti in 1990 to that in 1996?
Give a very brief answer. 0.76. What is the ratio of the Population(% of urban population) in Malaysia in 1990 to that in 1996?
Offer a very short reply. 0.66. What is the ratio of the Population(% of urban population) of El Salvador in 1991 to that in 1992?
Your answer should be very brief. 0.97. What is the ratio of the Population(% of urban population) of Haiti in 1991 to that in 1992?
Offer a very short reply. 0.95. What is the ratio of the Population(% of urban population) in El Salvador in 1991 to that in 1993?
Offer a very short reply. 0.96. What is the ratio of the Population(% of urban population) in Haiti in 1991 to that in 1993?
Offer a terse response. 0.91. What is the ratio of the Population(% of urban population) of Malaysia in 1991 to that in 1993?
Offer a terse response. 0.87. What is the ratio of the Population(% of urban population) in El Salvador in 1991 to that in 1994?
Provide a succinct answer. 0.96. What is the ratio of the Population(% of urban population) of Haiti in 1991 to that in 1994?
Provide a short and direct response. 0.87. What is the ratio of the Population(% of urban population) of Malaysia in 1991 to that in 1994?
Your answer should be very brief. 0.81. What is the ratio of the Population(% of urban population) of El Salvador in 1991 to that in 1995?
Offer a very short reply. 0.95. What is the ratio of the Population(% of urban population) in Haiti in 1991 to that in 1995?
Keep it short and to the point. 0.84. What is the ratio of the Population(% of urban population) in Malaysia in 1991 to that in 1995?
Ensure brevity in your answer.  0.76. What is the ratio of the Population(% of urban population) in El Salvador in 1991 to that in 1996?
Provide a short and direct response. 0.95. What is the ratio of the Population(% of urban population) in Haiti in 1991 to that in 1996?
Provide a succinct answer. 0.8. What is the ratio of the Population(% of urban population) of Malaysia in 1991 to that in 1996?
Give a very brief answer. 0.71. What is the ratio of the Population(% of urban population) in El Salvador in 1992 to that in 1993?
Make the answer very short. 0.99. What is the ratio of the Population(% of urban population) in Haiti in 1992 to that in 1993?
Your answer should be very brief. 0.96. What is the ratio of the Population(% of urban population) of Malaysia in 1992 to that in 1993?
Give a very brief answer. 0.93. What is the ratio of the Population(% of urban population) of El Salvador in 1992 to that in 1994?
Provide a succinct answer. 0.99. What is the ratio of the Population(% of urban population) in Haiti in 1992 to that in 1994?
Provide a short and direct response. 0.92. What is the ratio of the Population(% of urban population) of Malaysia in 1992 to that in 1994?
Your response must be concise. 0.87. What is the ratio of the Population(% of urban population) in El Salvador in 1992 to that in 1995?
Provide a succinct answer. 0.99. What is the ratio of the Population(% of urban population) of Haiti in 1992 to that in 1995?
Your answer should be very brief. 0.88. What is the ratio of the Population(% of urban population) in Malaysia in 1992 to that in 1995?
Your answer should be compact. 0.82. What is the ratio of the Population(% of urban population) of El Salvador in 1992 to that in 1996?
Provide a short and direct response. 0.98. What is the ratio of the Population(% of urban population) of Haiti in 1992 to that in 1996?
Provide a short and direct response. 0.84. What is the ratio of the Population(% of urban population) in Malaysia in 1992 to that in 1996?
Make the answer very short. 0.76. What is the ratio of the Population(% of urban population) in El Salvador in 1993 to that in 1994?
Make the answer very short. 1. What is the ratio of the Population(% of urban population) of Haiti in 1993 to that in 1994?
Ensure brevity in your answer.  0.96. What is the ratio of the Population(% of urban population) of Malaysia in 1993 to that in 1994?
Your answer should be compact. 0.93. What is the ratio of the Population(% of urban population) in Haiti in 1993 to that in 1995?
Offer a very short reply. 0.92. What is the ratio of the Population(% of urban population) of Malaysia in 1993 to that in 1995?
Your answer should be very brief. 0.87. What is the ratio of the Population(% of urban population) in El Salvador in 1993 to that in 1996?
Your answer should be very brief. 0.99. What is the ratio of the Population(% of urban population) of Haiti in 1993 to that in 1996?
Your response must be concise. 0.88. What is the ratio of the Population(% of urban population) in Malaysia in 1993 to that in 1996?
Offer a terse response. 0.82. What is the ratio of the Population(% of urban population) in El Salvador in 1994 to that in 1995?
Make the answer very short. 1. What is the ratio of the Population(% of urban population) in Haiti in 1994 to that in 1995?
Make the answer very short. 0.96. What is the ratio of the Population(% of urban population) in Malaysia in 1994 to that in 1995?
Make the answer very short. 0.93. What is the ratio of the Population(% of urban population) of El Salvador in 1994 to that in 1996?
Offer a terse response. 1. What is the ratio of the Population(% of urban population) in Haiti in 1994 to that in 1996?
Provide a succinct answer. 0.92. What is the ratio of the Population(% of urban population) of Malaysia in 1994 to that in 1996?
Provide a short and direct response. 0.87. What is the ratio of the Population(% of urban population) of Haiti in 1995 to that in 1996?
Ensure brevity in your answer.  0.96. What is the ratio of the Population(% of urban population) in Malaysia in 1995 to that in 1996?
Your response must be concise. 0.93. What is the difference between the highest and the second highest Population(% of urban population) of El Salvador?
Provide a short and direct response. 2432. What is the difference between the highest and the second highest Population(% of urban population) in Haiti?
Your answer should be very brief. 6.26e+04. What is the difference between the highest and the second highest Population(% of urban population) in Malaysia?
Keep it short and to the point. 2.09e+05. What is the difference between the highest and the lowest Population(% of urban population) of El Salvador?
Your response must be concise. 1.13e+05. What is the difference between the highest and the lowest Population(% of urban population) in Haiti?
Your answer should be compact. 4.12e+05. What is the difference between the highest and the lowest Population(% of urban population) in Malaysia?
Your answer should be very brief. 1.24e+06. 